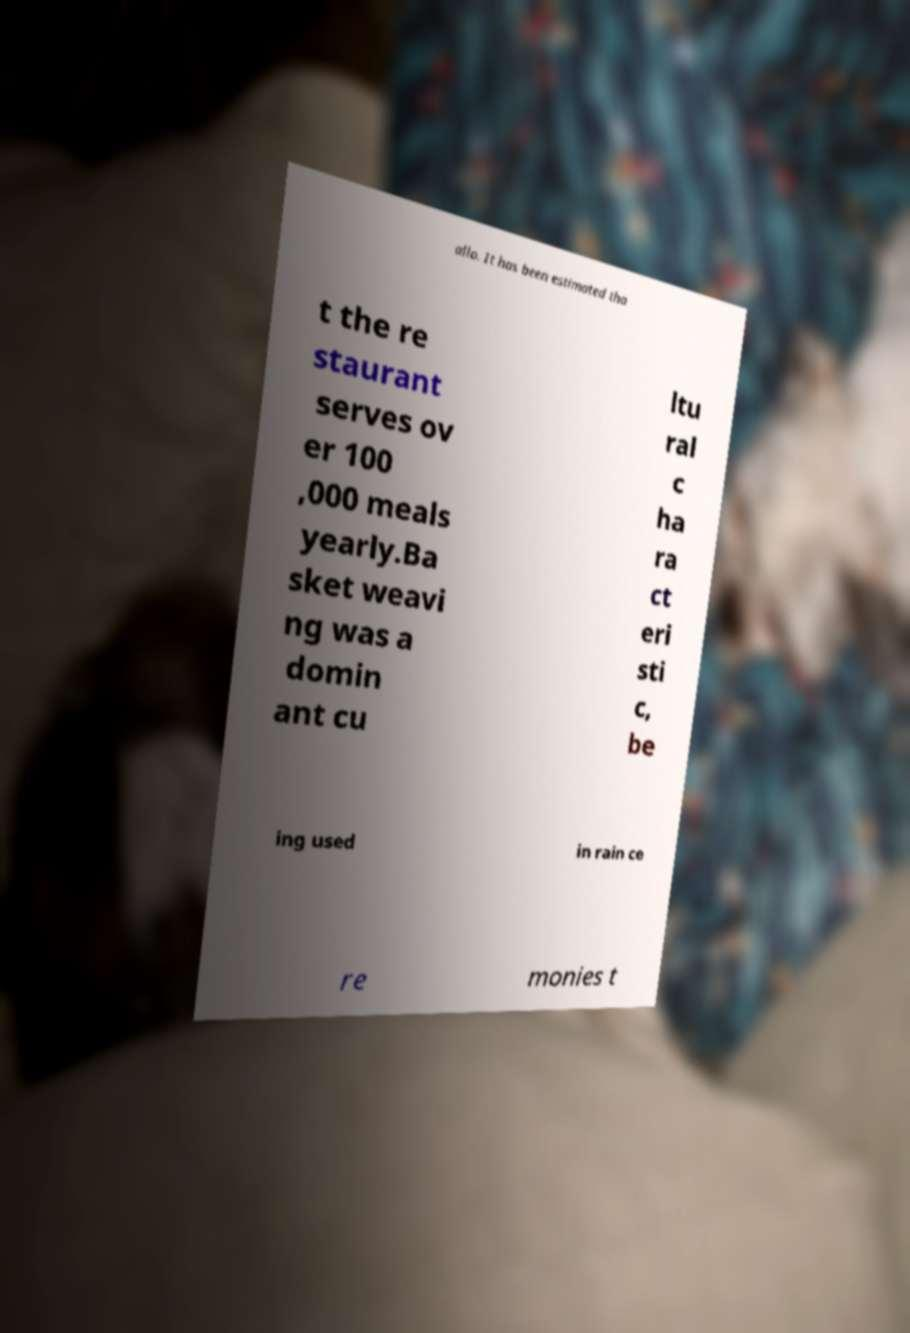Can you read and provide the text displayed in the image?This photo seems to have some interesting text. Can you extract and type it out for me? allo. It has been estimated tha t the re staurant serves ov er 100 ,000 meals yearly.Ba sket weavi ng was a domin ant cu ltu ral c ha ra ct eri sti c, be ing used in rain ce re monies t 